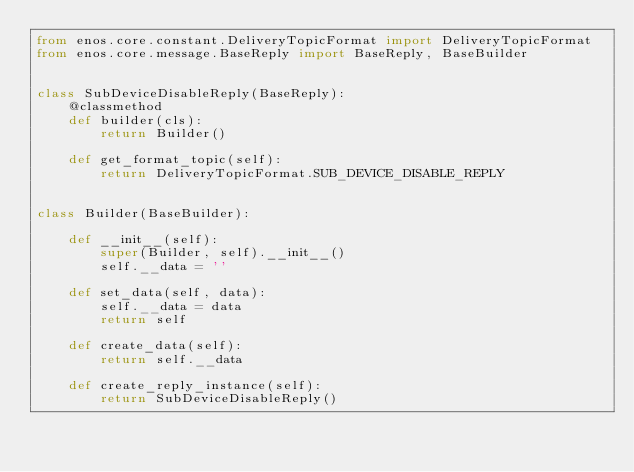<code> <loc_0><loc_0><loc_500><loc_500><_Python_>from enos.core.constant.DeliveryTopicFormat import DeliveryTopicFormat
from enos.core.message.BaseReply import BaseReply, BaseBuilder


class SubDeviceDisableReply(BaseReply):
    @classmethod
    def builder(cls):
        return Builder()

    def get_format_topic(self):
        return DeliveryTopicFormat.SUB_DEVICE_DISABLE_REPLY


class Builder(BaseBuilder):

    def __init__(self):
        super(Builder, self).__init__()
        self.__data = ''

    def set_data(self, data):
        self.__data = data
        return self

    def create_data(self):
        return self.__data

    def create_reply_instance(self):
        return SubDeviceDisableReply()

</code> 